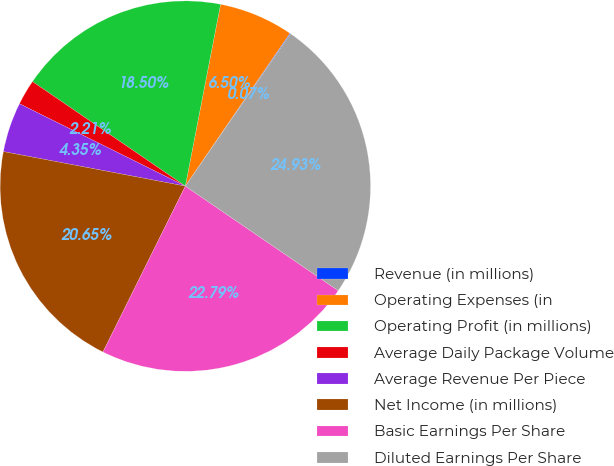<chart> <loc_0><loc_0><loc_500><loc_500><pie_chart><fcel>Revenue (in millions)<fcel>Operating Expenses (in<fcel>Operating Profit (in millions)<fcel>Average Daily Package Volume<fcel>Average Revenue Per Piece<fcel>Net Income (in millions)<fcel>Basic Earnings Per Share<fcel>Diluted Earnings Per Share<nl><fcel>0.07%<fcel>6.5%<fcel>18.5%<fcel>2.21%<fcel>4.35%<fcel>20.65%<fcel>22.79%<fcel>24.93%<nl></chart> 